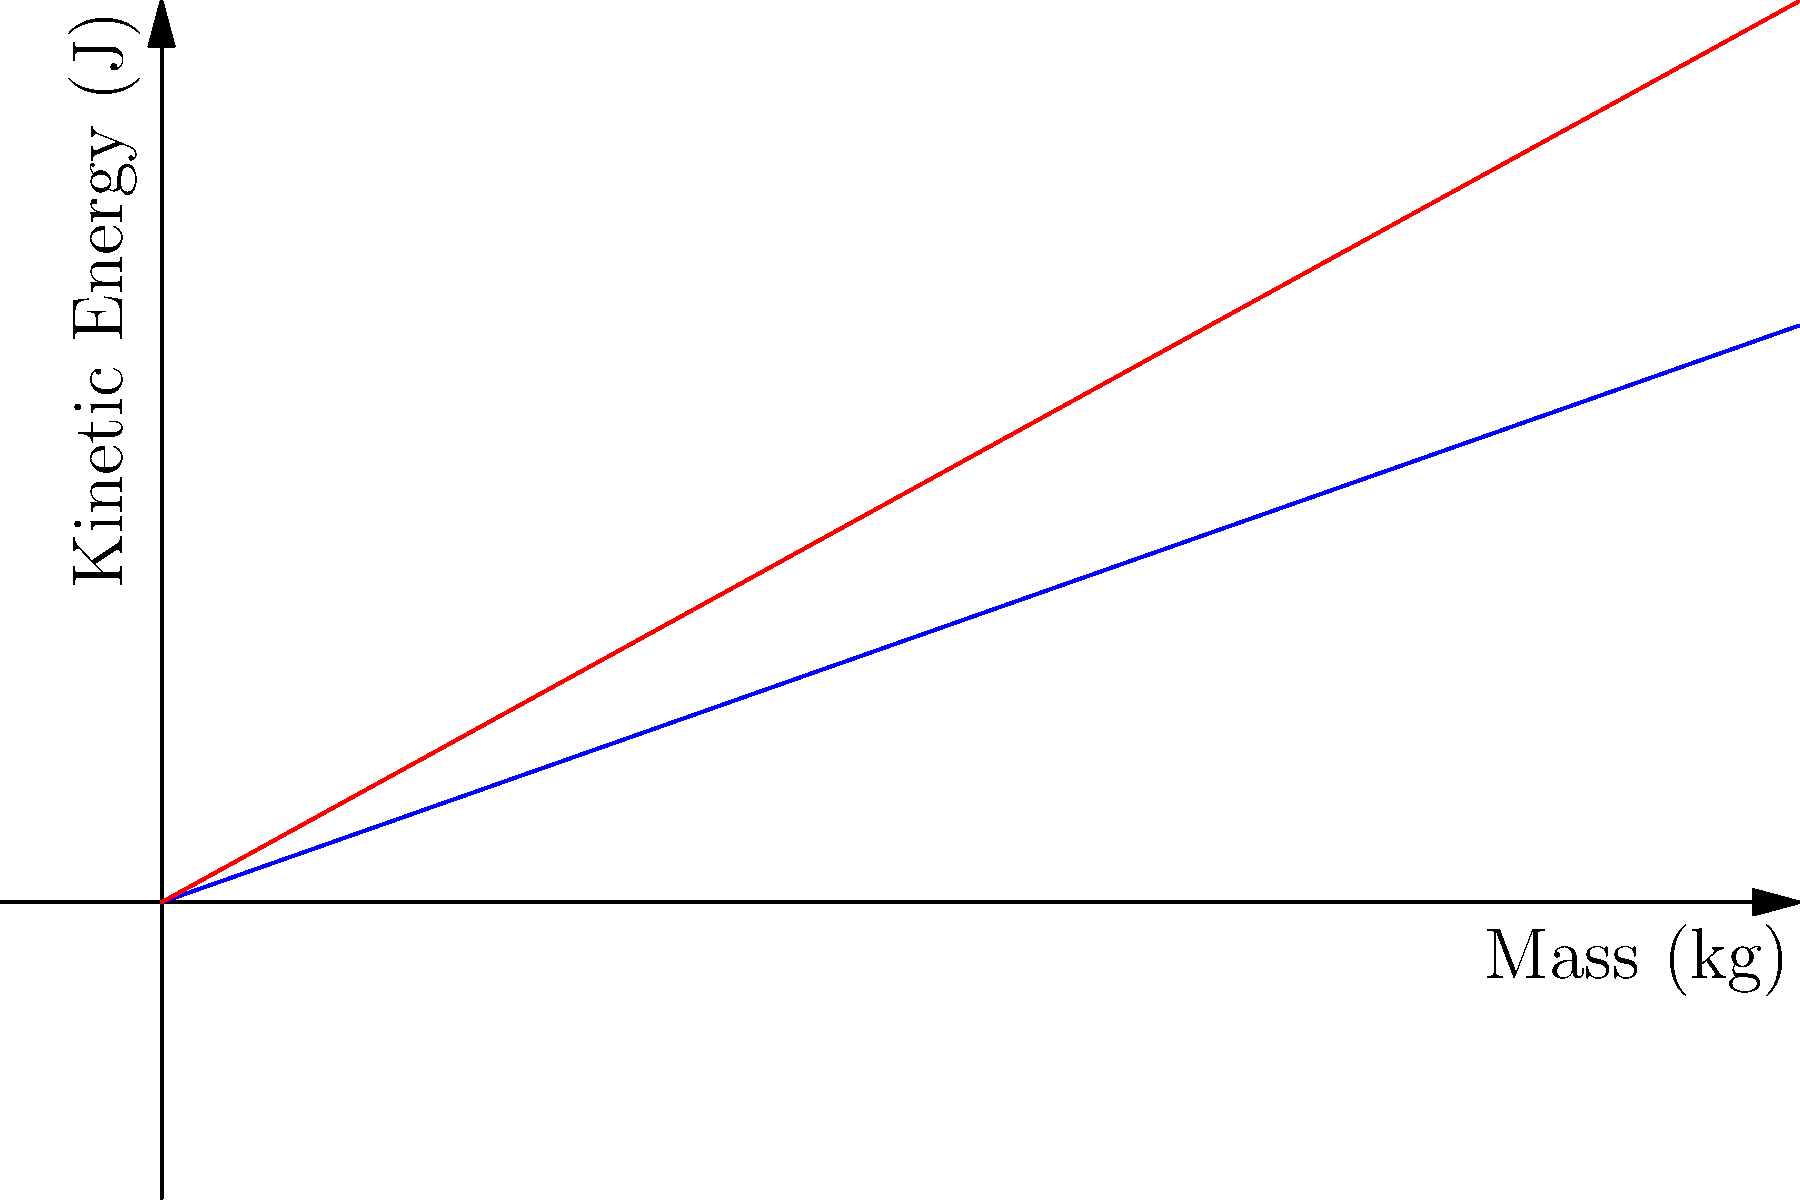As a transportation safety officer, you're analyzing the kinetic energy of vehicles with different masses traveling at various speeds. The graph shows the kinetic energy of vehicles with masses up to 5000 kg traveling at 80 km/h and 100 km/h. How much more kinetic energy does a 3000 kg truck have when traveling at 100 km/h compared to 80 km/h? To solve this problem, let's follow these steps:

1) The formula for kinetic energy is:
   $$KE = \frac{1}{2}mv^2$$
   where $m$ is mass in kg and $v$ is velocity in m/s.

2) We need to convert km/h to m/s:
   80 km/h = 80 * (1000/3600) = 22.22 m/s
   100 km/h = 100 * (1000/3600) = 27.78 m/s

3) Calculate the kinetic energy at 80 km/h:
   $$KE_{80} = \frac{1}{2} * 3000 * 22.22^2 = 740,740 \text{ J}$$

4) Calculate the kinetic energy at 100 km/h:
   $$KE_{100} = \frac{1}{2} * 3000 * 27.78^2 = 1,157,407 \text{ J}$$

5) Find the difference:
   $$\Delta KE = KE_{100} - KE_{80} = 1,157,407 - 740,740 = 416,667 \text{ J}$$

Therefore, the truck has 416,667 J more kinetic energy when traveling at 100 km/h compared to 80 km/h.
Answer: 416,667 J 